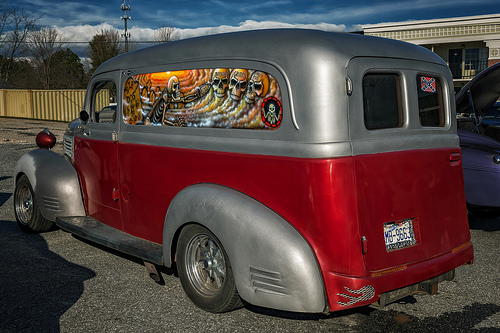<image>
Is the car in the car? No. The car is not contained within the car. These objects have a different spatial relationship. 